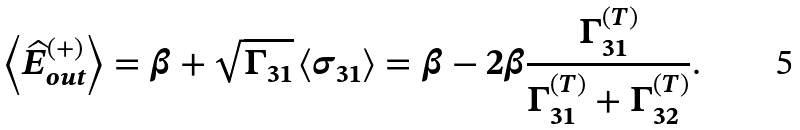Convert formula to latex. <formula><loc_0><loc_0><loc_500><loc_500>\left \langle \widehat { E } _ { o u t } ^ { ( + ) } \right \rangle = \beta + \sqrt { \Gamma _ { 3 1 } } \left \langle \sigma _ { 3 1 } \right \rangle = \beta - 2 \beta \frac { \Gamma _ { 3 1 } ^ { ( T ) } } { \Gamma _ { 3 1 } ^ { ( T ) } + \Gamma _ { 3 2 } ^ { ( T ) } } .</formula> 